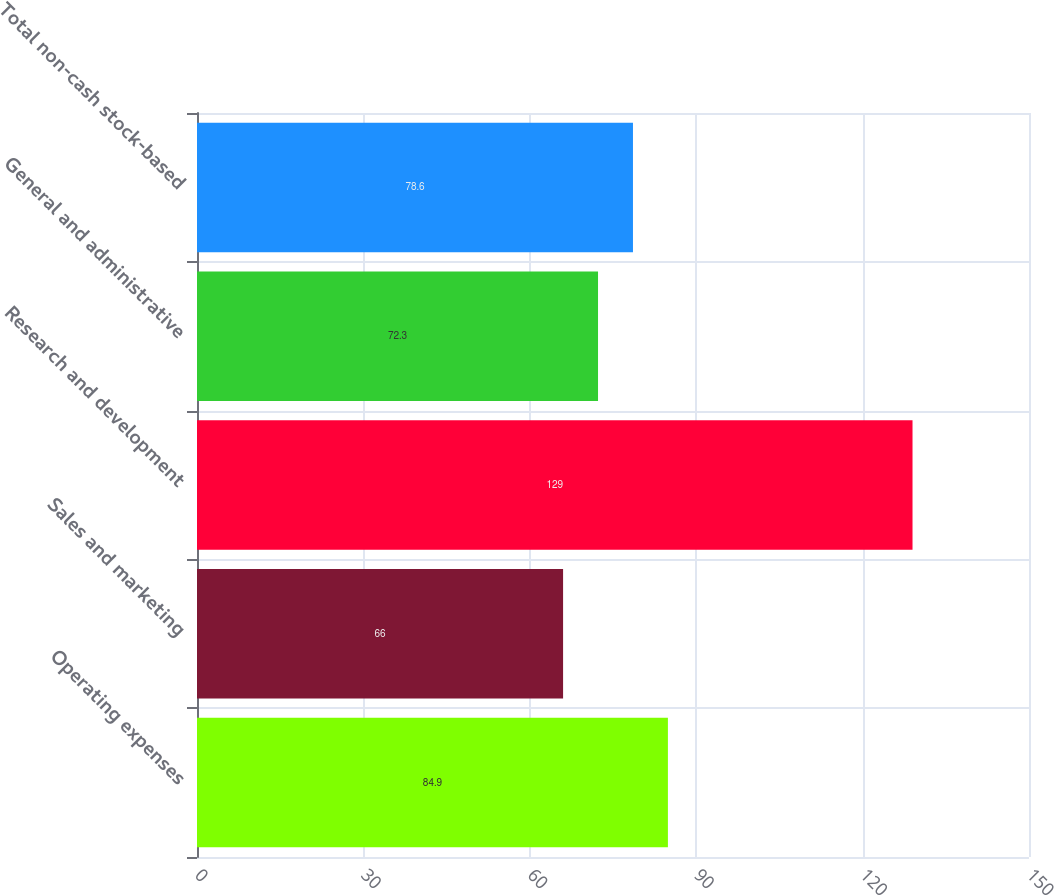Convert chart to OTSL. <chart><loc_0><loc_0><loc_500><loc_500><bar_chart><fcel>Operating expenses<fcel>Sales and marketing<fcel>Research and development<fcel>General and administrative<fcel>Total non-cash stock-based<nl><fcel>84.9<fcel>66<fcel>129<fcel>72.3<fcel>78.6<nl></chart> 